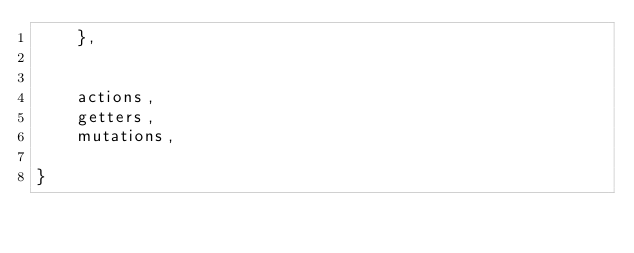Convert code to text. <code><loc_0><loc_0><loc_500><loc_500><_JavaScript_>    },


    actions,
    getters,
    mutations,

}</code> 